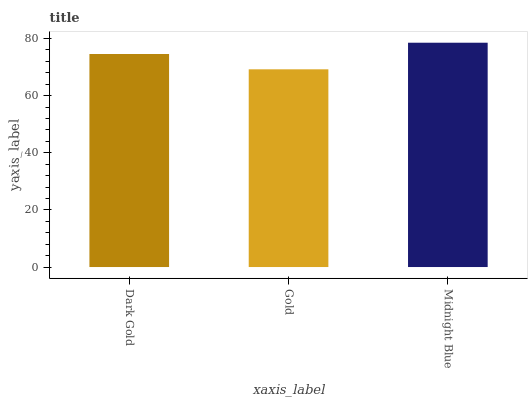Is Gold the minimum?
Answer yes or no. Yes. Is Midnight Blue the maximum?
Answer yes or no. Yes. Is Midnight Blue the minimum?
Answer yes or no. No. Is Gold the maximum?
Answer yes or no. No. Is Midnight Blue greater than Gold?
Answer yes or no. Yes. Is Gold less than Midnight Blue?
Answer yes or no. Yes. Is Gold greater than Midnight Blue?
Answer yes or no. No. Is Midnight Blue less than Gold?
Answer yes or no. No. Is Dark Gold the high median?
Answer yes or no. Yes. Is Dark Gold the low median?
Answer yes or no. Yes. Is Gold the high median?
Answer yes or no. No. Is Midnight Blue the low median?
Answer yes or no. No. 